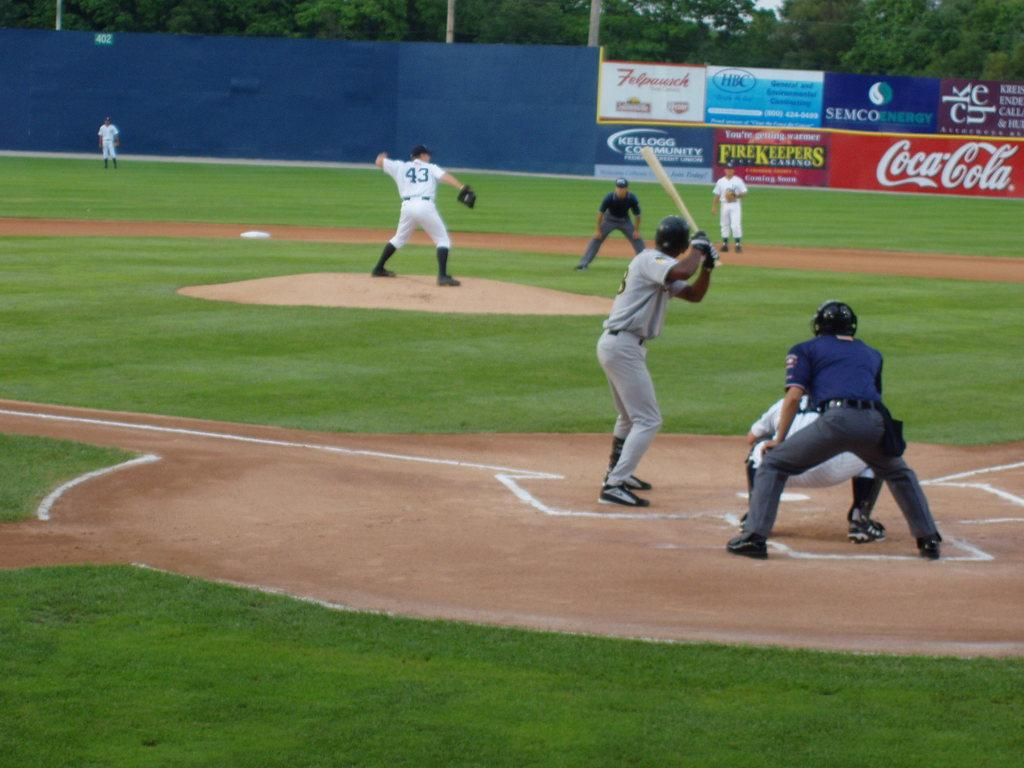<image>
Render a clear and concise summary of the photo. Man wearing jersey number 43 getting ready to pitch the ball. 